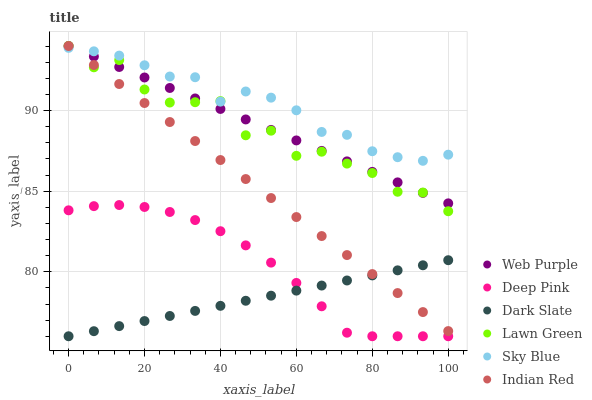Does Dark Slate have the minimum area under the curve?
Answer yes or no. Yes. Does Sky Blue have the maximum area under the curve?
Answer yes or no. Yes. Does Deep Pink have the minimum area under the curve?
Answer yes or no. No. Does Deep Pink have the maximum area under the curve?
Answer yes or no. No. Is Dark Slate the smoothest?
Answer yes or no. Yes. Is Lawn Green the roughest?
Answer yes or no. Yes. Is Deep Pink the smoothest?
Answer yes or no. No. Is Deep Pink the roughest?
Answer yes or no. No. Does Deep Pink have the lowest value?
Answer yes or no. Yes. Does Web Purple have the lowest value?
Answer yes or no. No. Does Indian Red have the highest value?
Answer yes or no. Yes. Does Deep Pink have the highest value?
Answer yes or no. No. Is Dark Slate less than Lawn Green?
Answer yes or no. Yes. Is Lawn Green greater than Dark Slate?
Answer yes or no. Yes. Does Indian Red intersect Dark Slate?
Answer yes or no. Yes. Is Indian Red less than Dark Slate?
Answer yes or no. No. Is Indian Red greater than Dark Slate?
Answer yes or no. No. Does Dark Slate intersect Lawn Green?
Answer yes or no. No. 